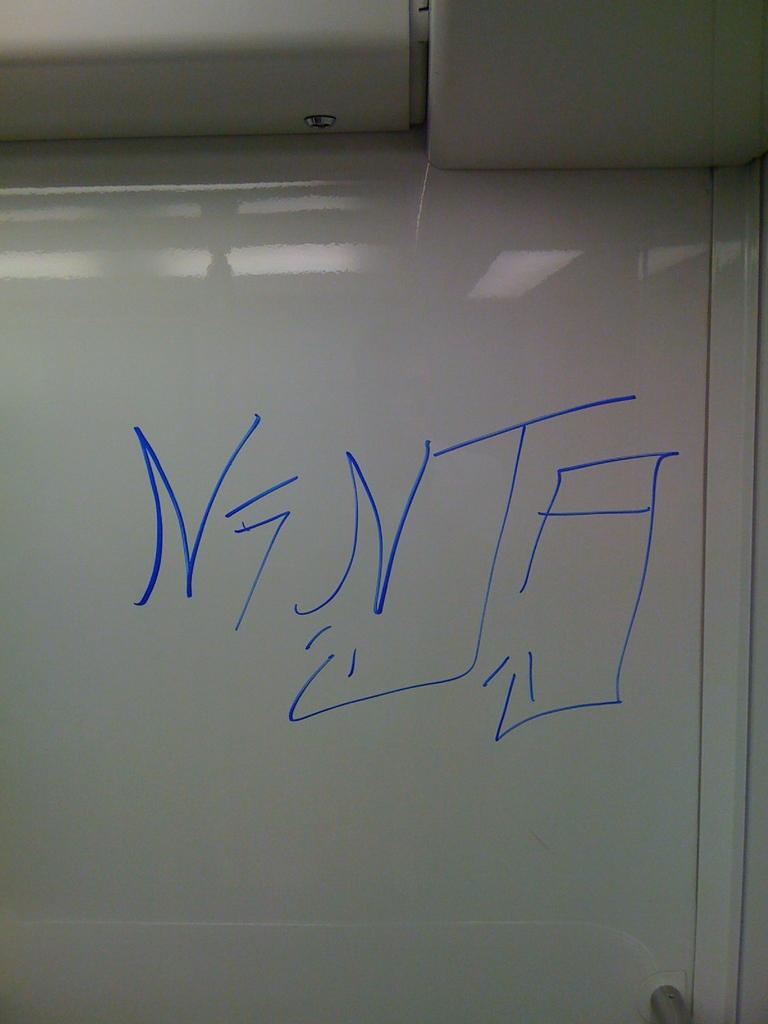<image>
Give a short and clear explanation of the subsequent image. a wall with the word N7NJA wrote on it 